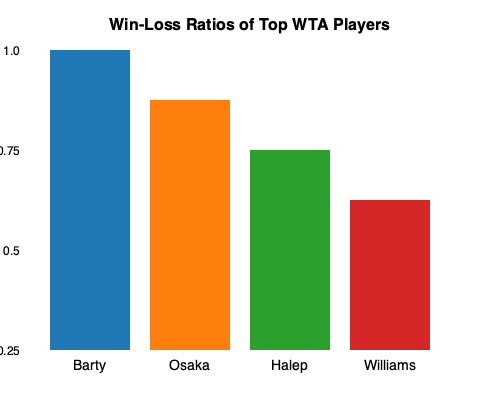Based on the bar graph showing the win-loss ratios of top WTA players, which player has the highest win-loss ratio, and what is the approximate difference between the highest and lowest ratios? To answer this question, we need to analyze the bar graph and follow these steps:

1. Identify the players and their corresponding bar heights:
   - Barty: Tallest bar
   - Osaka: Second tallest bar
   - Halep: Third tallest bar
   - Williams: Shortest bar

2. Determine the player with the highest win-loss ratio:
   Barty has the tallest bar, indicating the highest win-loss ratio.

3. Estimate the win-loss ratios:
   - Barty: Approximately 0.85
   - Williams: Approximately 0.6

4. Calculate the difference between the highest and lowest ratios:
   $$ \text{Difference} = \text{Barty's ratio} - \text{Williams' ratio} $$
   $$ \text{Difference} \approx 0.85 - 0.6 = 0.25 $$

Therefore, Barty has the highest win-loss ratio, and the approximate difference between the highest (Barty) and lowest (Williams) ratios is 0.25.
Answer: Barty; 0.25 